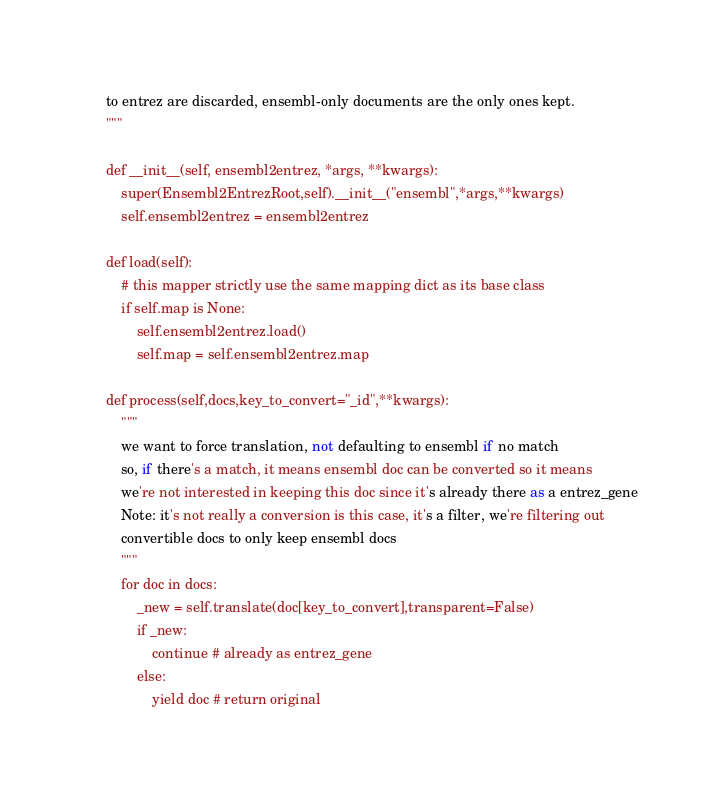Convert code to text. <code><loc_0><loc_0><loc_500><loc_500><_Python_>    to entrez are discarded, ensembl-only documents are the only ones kept.
    """

    def __init__(self, ensembl2entrez, *args, **kwargs):
        super(Ensembl2EntrezRoot,self).__init__("ensembl",*args,**kwargs)
        self.ensembl2entrez = ensembl2entrez

    def load(self):
        # this mapper strictly use the same mapping dict as its base class
        if self.map is None:
            self.ensembl2entrez.load()
            self.map = self.ensembl2entrez.map

    def process(self,docs,key_to_convert="_id",**kwargs):
        """
        we want to force translation, not defaulting to ensembl if no match
        so, if there's a match, it means ensembl doc can be converted so it means
        we're not interested in keeping this doc since it's already there as a entrez_gene
        Note: it's not really a conversion is this case, it's a filter, we're filtering out
        convertible docs to only keep ensembl docs
        """
        for doc in docs:
            _new = self.translate(doc[key_to_convert],transparent=False)
            if _new:
                continue # already as entrez_gene
            else:
                yield doc # return original
</code> 